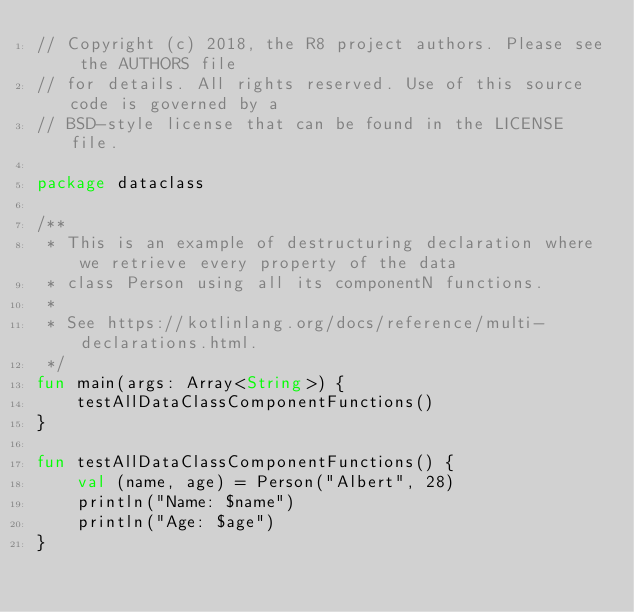Convert code to text. <code><loc_0><loc_0><loc_500><loc_500><_Kotlin_>// Copyright (c) 2018, the R8 project authors. Please see the AUTHORS file
// for details. All rights reserved. Use of this source code is governed by a
// BSD-style license that can be found in the LICENSE file.

package dataclass

/**
 * This is an example of destructuring declaration where we retrieve every property of the data
 * class Person using all its componentN functions.
 *
 * See https://kotlinlang.org/docs/reference/multi-declarations.html.
 */
fun main(args: Array<String>) {
    testAllDataClassComponentFunctions()
}

fun testAllDataClassComponentFunctions() {
    val (name, age) = Person("Albert", 28)
    println("Name: $name")
    println("Age: $age")
}</code> 